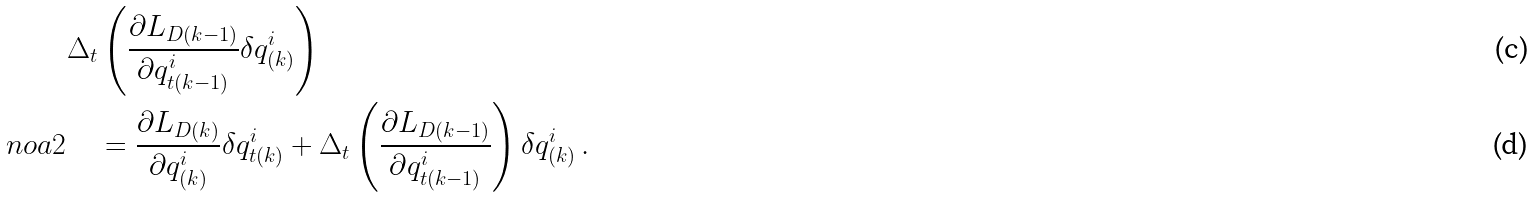<formula> <loc_0><loc_0><loc_500><loc_500>& \Delta _ { t } \left ( \frac { \partial L _ { D ( k - 1 ) } } { \partial q ^ { i } _ { t ( k - 1 ) } } \delta q ^ { i } _ { ( k ) } \right ) \\ \ n o a 2 & \quad = \frac { \partial L _ { D ( k ) } } { \partial q ^ { i } _ { ( k ) } } \delta q ^ { i } _ { t ( k ) } + \Delta _ { t } \left ( \frac { \partial L _ { D ( k - 1 ) } } { \partial q ^ { i } _ { t ( k - 1 ) } } \right ) \delta q ^ { i } _ { ( k ) } \, .</formula> 